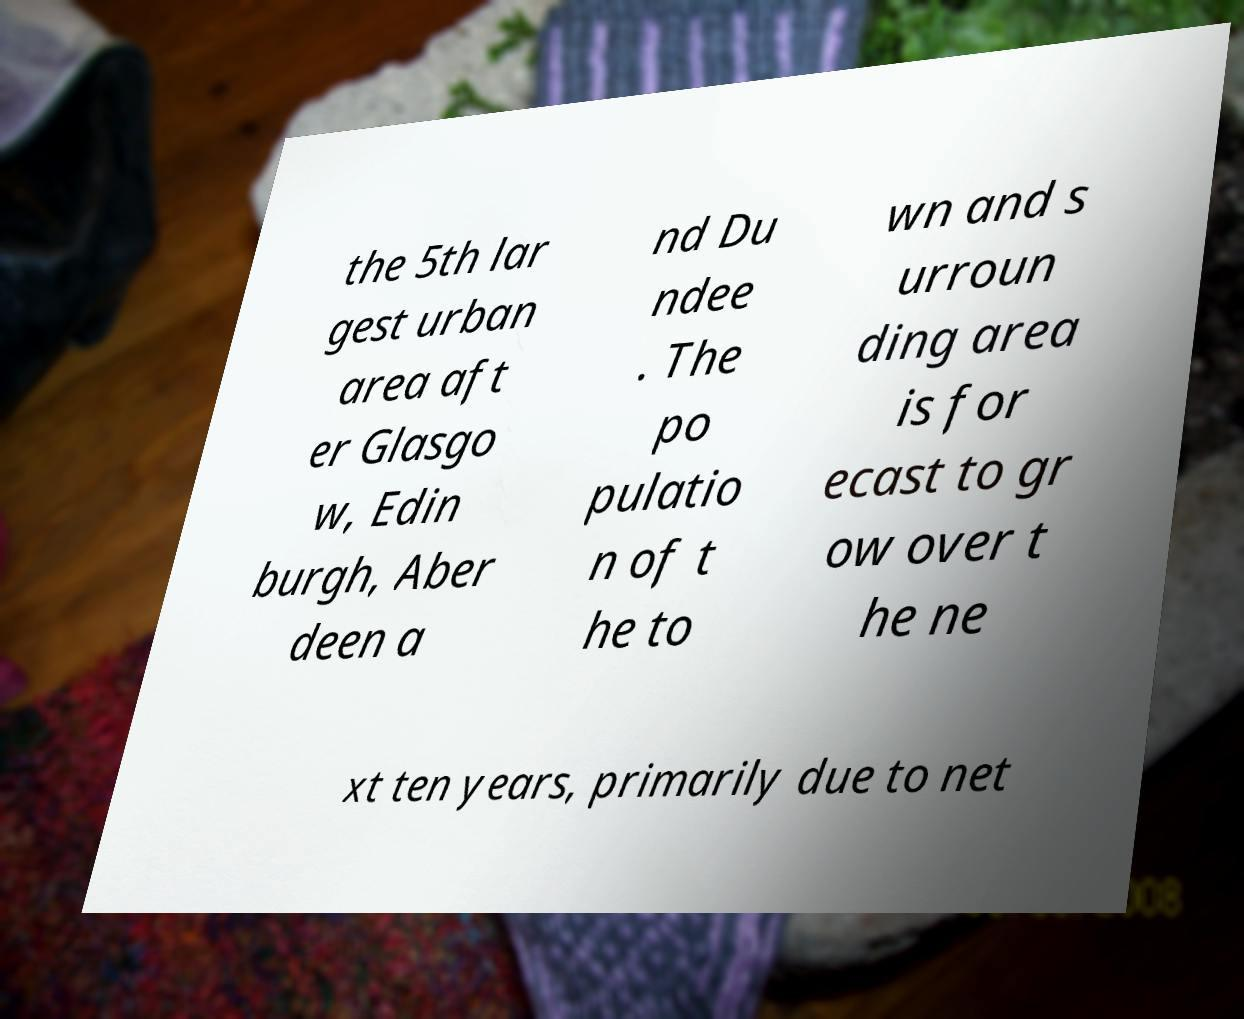Can you read and provide the text displayed in the image?This photo seems to have some interesting text. Can you extract and type it out for me? the 5th lar gest urban area aft er Glasgo w, Edin burgh, Aber deen a nd Du ndee . The po pulatio n of t he to wn and s urroun ding area is for ecast to gr ow over t he ne xt ten years, primarily due to net 